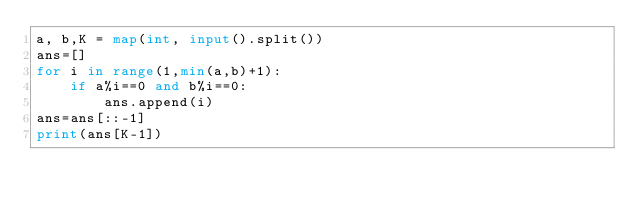<code> <loc_0><loc_0><loc_500><loc_500><_Python_>a, b,K = map(int, input().split())
ans=[]
for i in range(1,min(a,b)+1):
    if a%i==0 and b%i==0:
        ans.append(i)
ans=ans[::-1]
print(ans[K-1])
</code> 